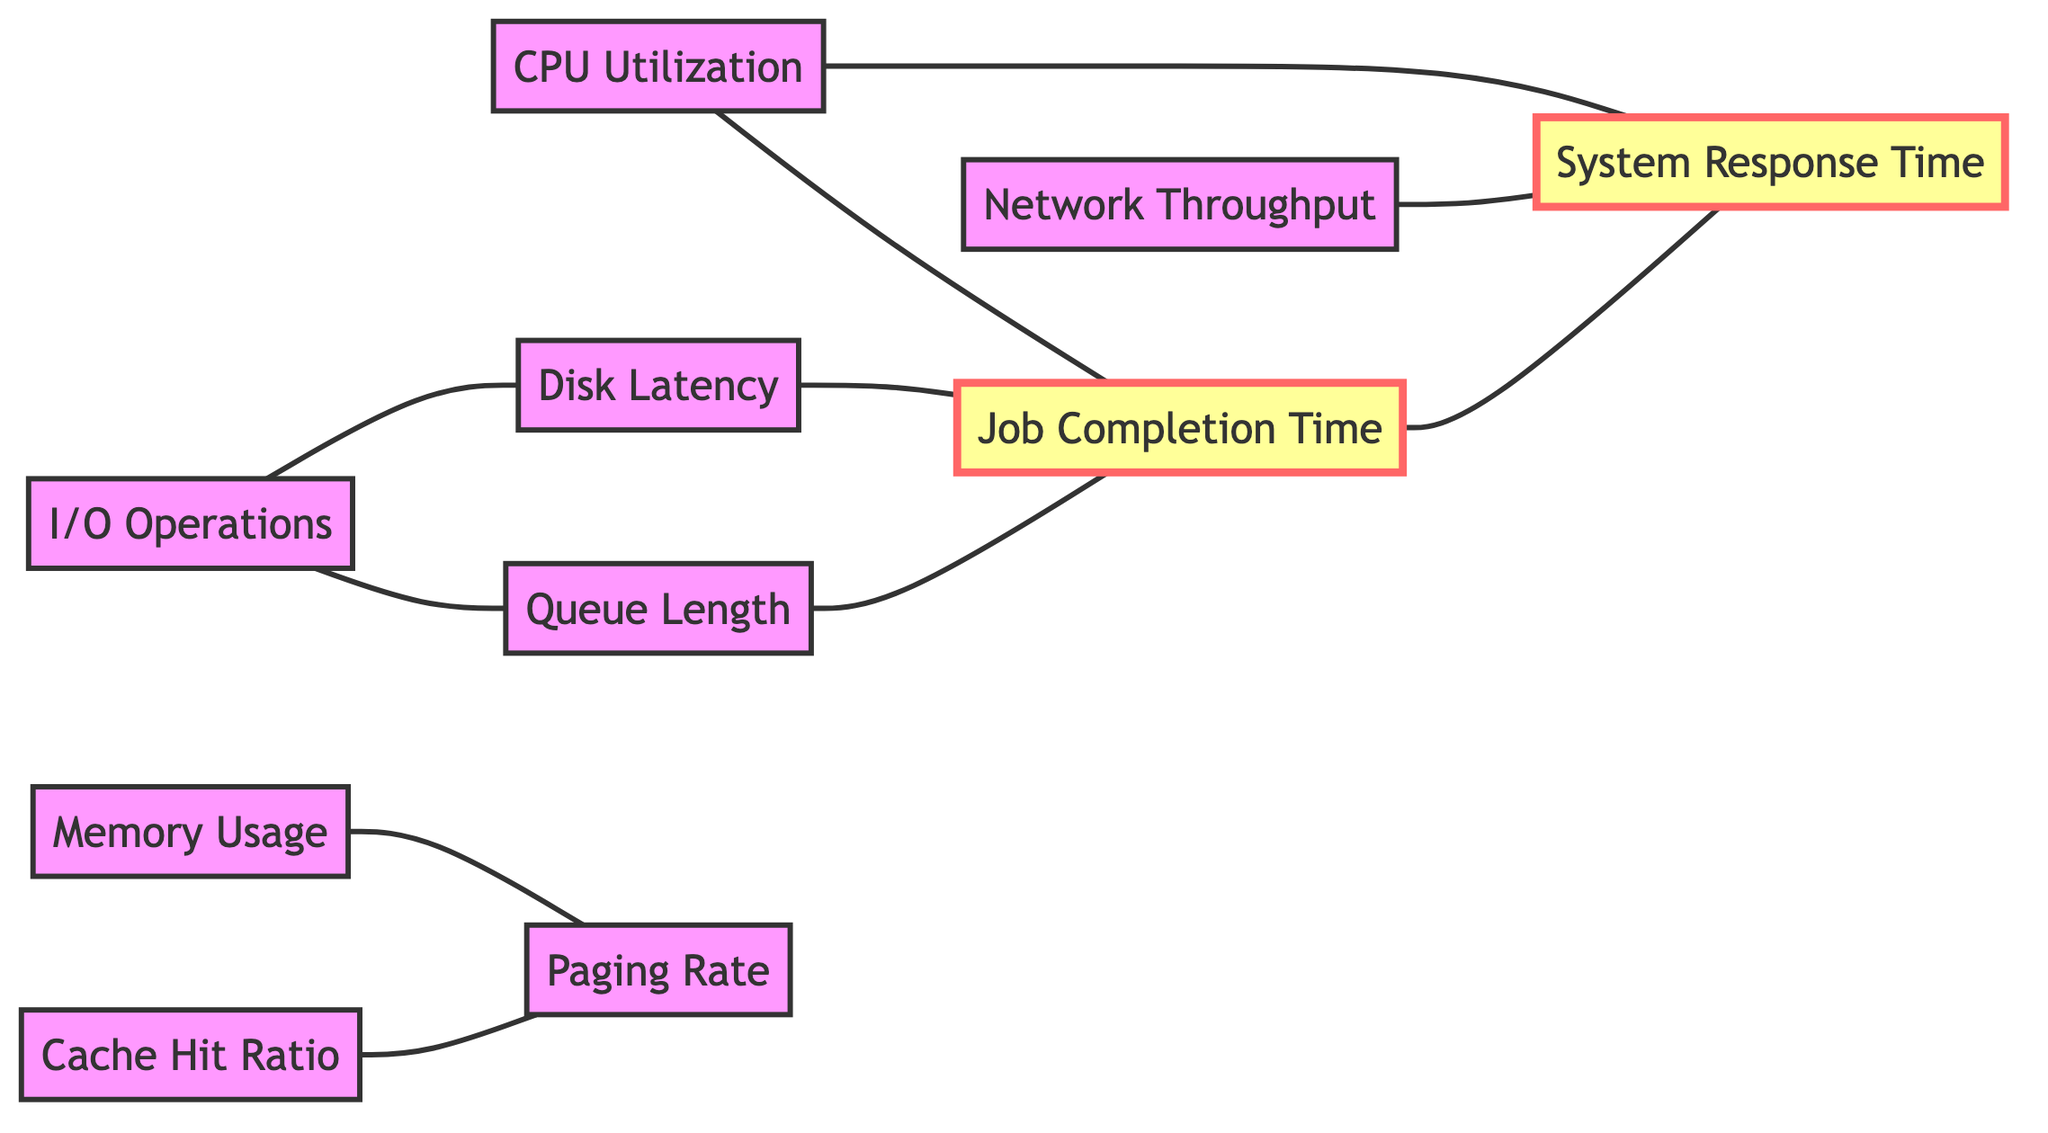What are the total number of nodes in the diagram? The diagram lists 10 distinct key performance metrics represented as nodes. Therefore, total nodes = 10.
Answer: 10 Which two nodes are directly connected to 'CPU Utilization'? 'CPU Utilization' is linked to 'Job Completion Time' and 'System Response Time'. These are the two connections identified from the edges.
Answer: Job Completion Time, System Response Time How many edges are there in total? The total count of connections (edges) displayed in the diagram is 10, which connects various nodes.
Answer: 10 What metric does 'Disk Latency' influence? 'Disk Latency' has a direct connection to 'Job Completion Time', indicating that it influences this performance metric.
Answer: Job Completion Time Which two nodes have the highest number of connections? By reviewing the connections, 'Job Completion Time' and 'System Response Time' both interact with four other metrics, making them the most connected nodes in the graph.
Answer: Job Completion Time, System Response Time What performance metric is related to both 'Memory Usage' and 'Cache Hit Ratio'? 'Paging Rate' is the common node that is connected to both 'Memory Usage' and 'Cache Hit Ratio' in the graph.
Answer: Paging Rate Which node is connected to 'I/O Operations' that is not 'Disk Latency'? The node connected to 'I/O Operations' other than 'Disk Latency' is 'Queue Length', as per the edges defined in the diagram.
Answer: Queue Length If 'Network Throughput' increases, which metric is likely to be affected? 'Network Throughput' is linked to 'System Response Time', meaning an increase in 'Network Throughput' is likely to influence 'System Response Time'.
Answer: System Response Time How many connections does 'Queue Length' have? The 'Queue Length' node has two direct connections: it connects to 'I/O Operations' and 'Job Completion Time', totaling to two edges.
Answer: 2 